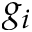<formula> <loc_0><loc_0><loc_500><loc_500>g _ { i }</formula> 